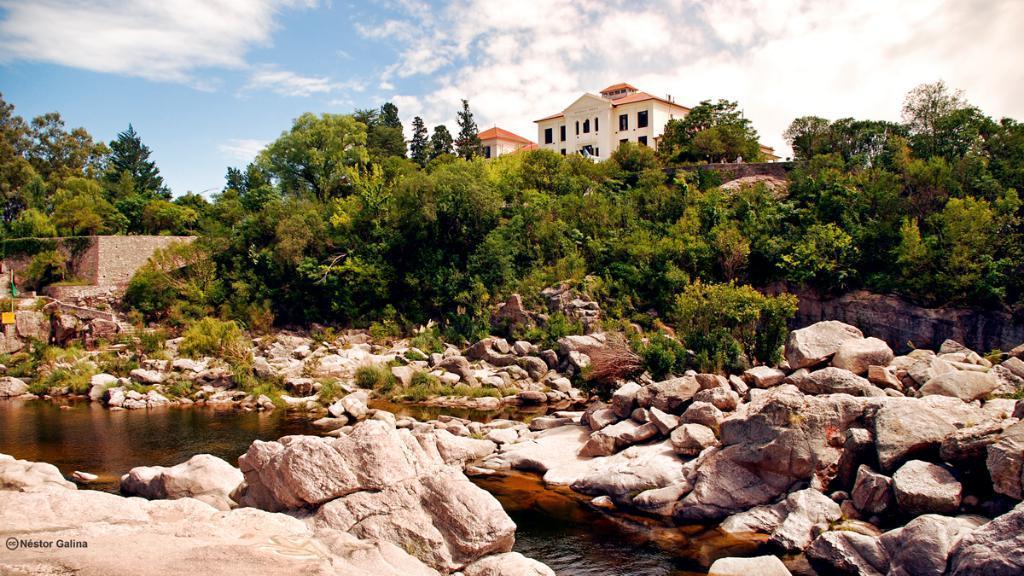Could you give a brief overview of what you see in this image? In this image I can see few rocks, the water, some grass and few trees. In the background I can see the building and the sky. 